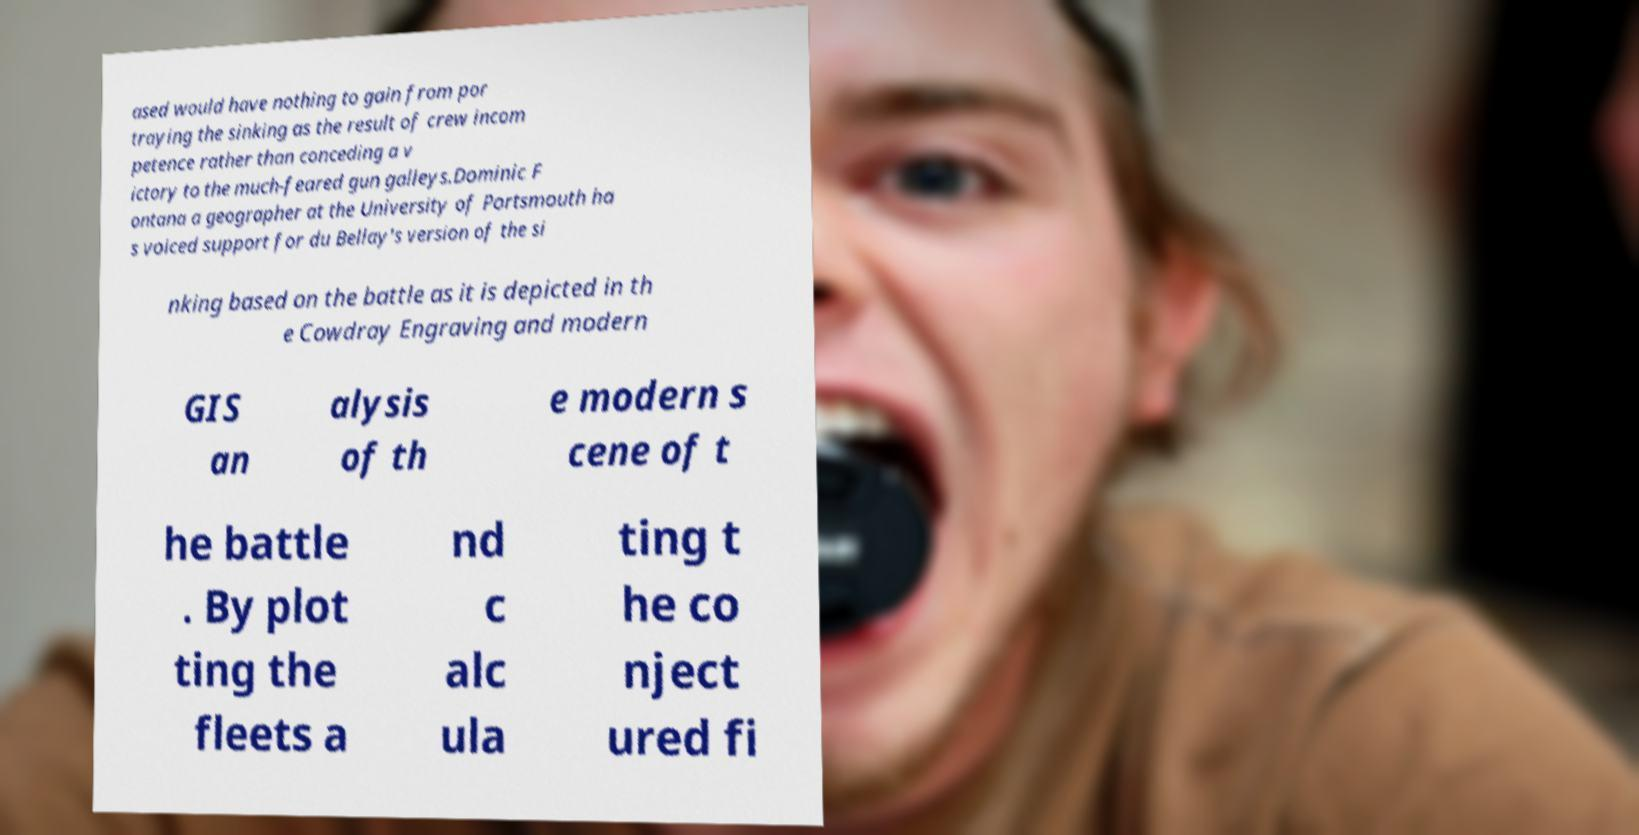What messages or text are displayed in this image? I need them in a readable, typed format. ased would have nothing to gain from por traying the sinking as the result of crew incom petence rather than conceding a v ictory to the much-feared gun galleys.Dominic F ontana a geographer at the University of Portsmouth ha s voiced support for du Bellay's version of the si nking based on the battle as it is depicted in th e Cowdray Engraving and modern GIS an alysis of th e modern s cene of t he battle . By plot ting the fleets a nd c alc ula ting t he co nject ured fi 